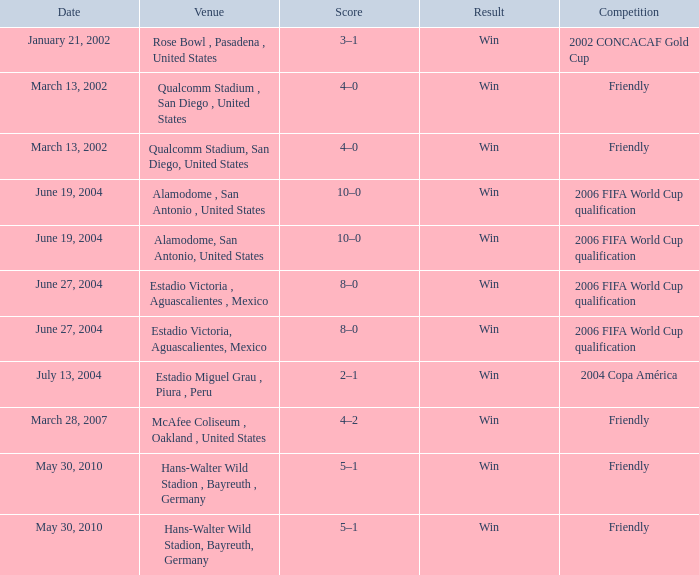What result has January 21, 2002 as the date? Win. 